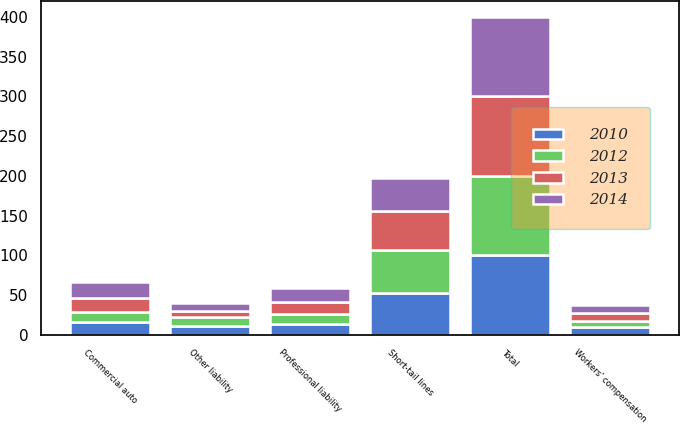<chart> <loc_0><loc_0><loc_500><loc_500><stacked_bar_chart><ecel><fcel>Short-tail lines<fcel>Commercial auto<fcel>Professional liability<fcel>Other liability<fcel>Workers' compensation<fcel>Total<nl><fcel>2012<fcel>55.1<fcel>13.1<fcel>12.8<fcel>11.7<fcel>7.3<fcel>100<nl><fcel>2010<fcel>51.8<fcel>15.5<fcel>12.9<fcel>10.4<fcel>9.4<fcel>100<nl><fcel>2013<fcel>49.4<fcel>18<fcel>15.1<fcel>7.2<fcel>10.3<fcel>100<nl><fcel>2014<fcel>41.4<fcel>19.8<fcel>17.6<fcel>10.3<fcel>10.9<fcel>100<nl></chart> 